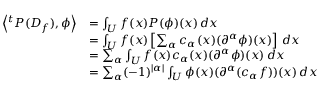<formula> <loc_0><loc_0><loc_500><loc_500>{ \begin{array} { r l } { \left \langle ^ { t } P ( D _ { f } ) , \phi \right \rangle } & { = \int _ { U } f ( x ) P ( \phi ) ( x ) \, d x } \\ & { = \int _ { U } f ( x ) \left [ \sum _ { \alpha } c _ { \alpha } ( x ) ( \partial ^ { \alpha } \phi ) ( x ) \right ] \, d x } \\ & { = \sum _ { \alpha } \int _ { U } f ( x ) c _ { \alpha } ( x ) ( \partial ^ { \alpha } \phi ) ( x ) \, d x } \\ & { = \sum _ { \alpha } ( - 1 ) ^ { | \alpha | } \int _ { U } \phi ( x ) ( \partial ^ { \alpha } ( c _ { \alpha } f ) ) ( x ) \, d x } \end{array} }</formula> 